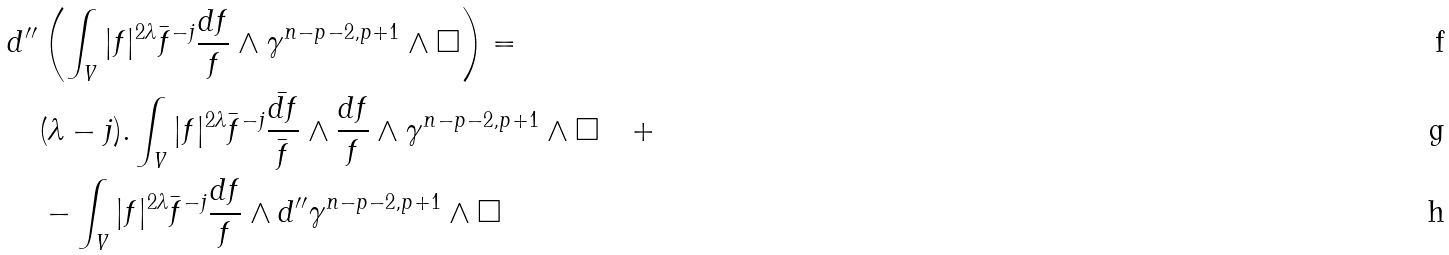Convert formula to latex. <formula><loc_0><loc_0><loc_500><loc_500>& d ^ { \prime \prime } \left ( \int _ { V } | f | ^ { 2 \lambda } \bar { f } ^ { - j } \frac { d f } { f } \wedge \gamma ^ { n - p - 2 , p + 1 } \wedge \Box \right ) = \\ & \quad ( \lambda - j ) . \int _ { V } | f | ^ { 2 \lambda } \bar { f } ^ { - j } \frac { \bar { d f } } { \bar { f } } \wedge \frac { d f } { f } \wedge \gamma ^ { n - p - 2 , p + 1 } \wedge \Box \quad + \\ & \quad - \int _ { V } | f | ^ { 2 \lambda } \bar { f } ^ { - j } \frac { d f } { f } \wedge d ^ { \prime \prime } \gamma ^ { n - p - 2 , p + 1 } \wedge \Box</formula> 